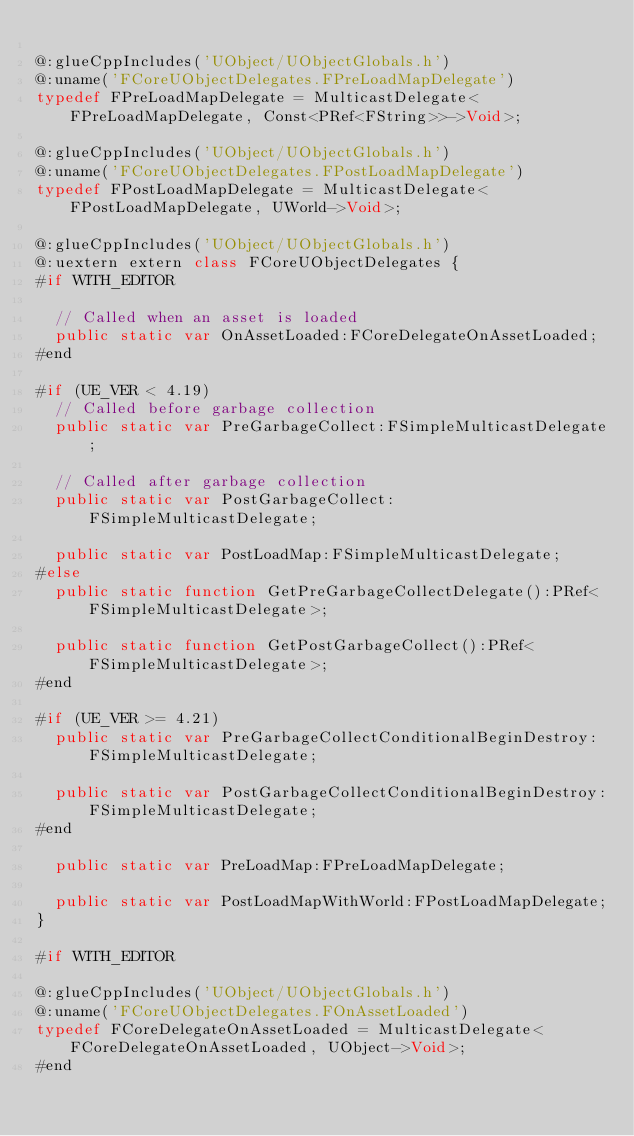<code> <loc_0><loc_0><loc_500><loc_500><_Haxe_>
@:glueCppIncludes('UObject/UObjectGlobals.h')
@:uname('FCoreUObjectDelegates.FPreLoadMapDelegate')
typedef FPreLoadMapDelegate = MulticastDelegate<FPreLoadMapDelegate, Const<PRef<FString>>->Void>;

@:glueCppIncludes('UObject/UObjectGlobals.h')
@:uname('FCoreUObjectDelegates.FPostLoadMapDelegate')
typedef FPostLoadMapDelegate = MulticastDelegate<FPostLoadMapDelegate, UWorld->Void>;

@:glueCppIncludes('UObject/UObjectGlobals.h')
@:uextern extern class FCoreUObjectDelegates {
#if WITH_EDITOR

  // Called when an asset is loaded
  public static var OnAssetLoaded:FCoreDelegateOnAssetLoaded;
#end

#if (UE_VER < 4.19)
  // Called before garbage collection
  public static var PreGarbageCollect:FSimpleMulticastDelegate;

  // Called after garbage collection
  public static var PostGarbageCollect:FSimpleMulticastDelegate;

  public static var PostLoadMap:FSimpleMulticastDelegate;
#else
  public static function GetPreGarbageCollectDelegate():PRef<FSimpleMulticastDelegate>;

  public static function GetPostGarbageCollect():PRef<FSimpleMulticastDelegate>;
#end

#if (UE_VER >= 4.21)
  public static var PreGarbageCollectConditionalBeginDestroy:FSimpleMulticastDelegate;

  public static var PostGarbageCollectConditionalBeginDestroy:FSimpleMulticastDelegate;
#end

  public static var PreLoadMap:FPreLoadMapDelegate;

  public static var PostLoadMapWithWorld:FPostLoadMapDelegate;
}

#if WITH_EDITOR

@:glueCppIncludes('UObject/UObjectGlobals.h')
@:uname('FCoreUObjectDelegates.FOnAssetLoaded')
typedef FCoreDelegateOnAssetLoaded = MulticastDelegate<FCoreDelegateOnAssetLoaded, UObject->Void>;
#end
</code> 